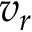<formula> <loc_0><loc_0><loc_500><loc_500>v _ { r }</formula> 